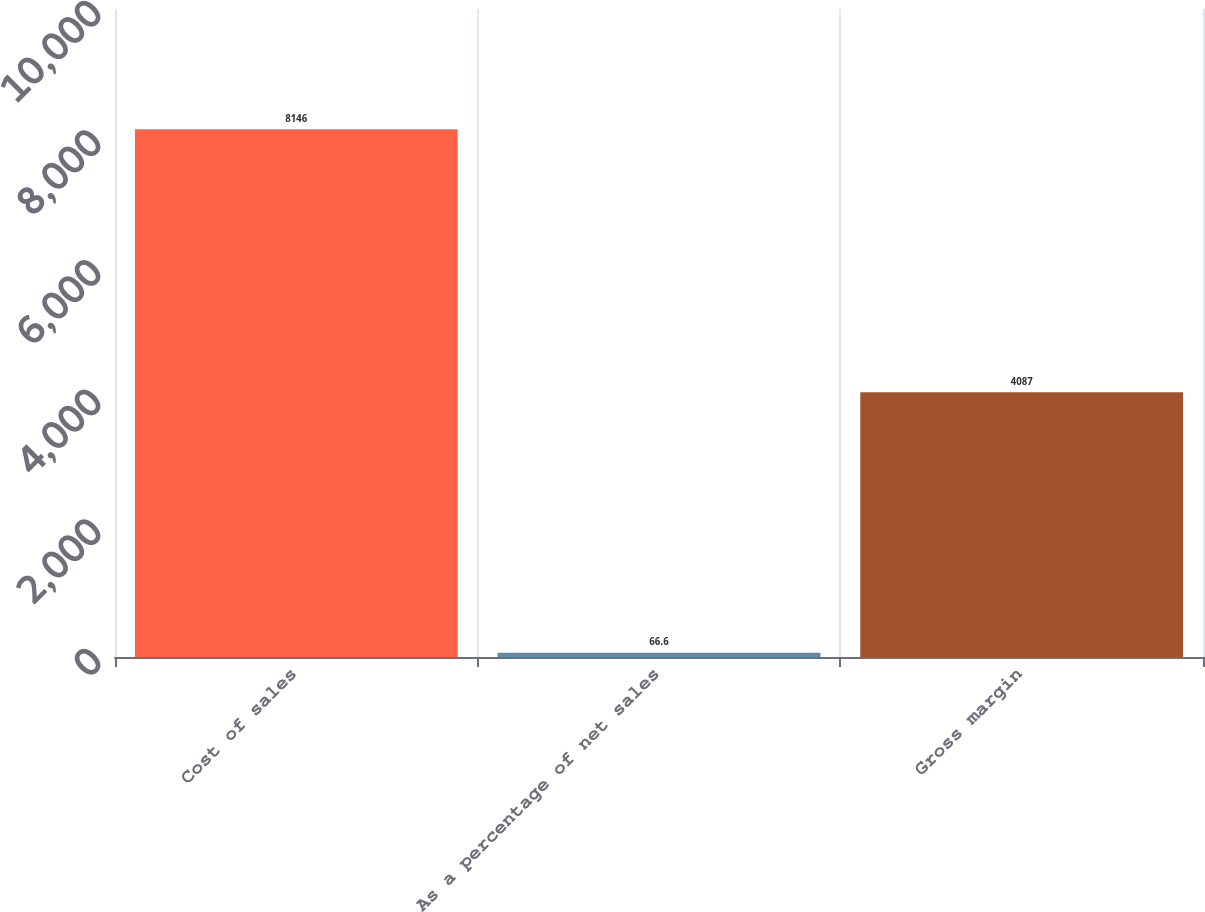<chart> <loc_0><loc_0><loc_500><loc_500><bar_chart><fcel>Cost of sales<fcel>As a percentage of net sales<fcel>Gross margin<nl><fcel>8146<fcel>66.6<fcel>4087<nl></chart> 